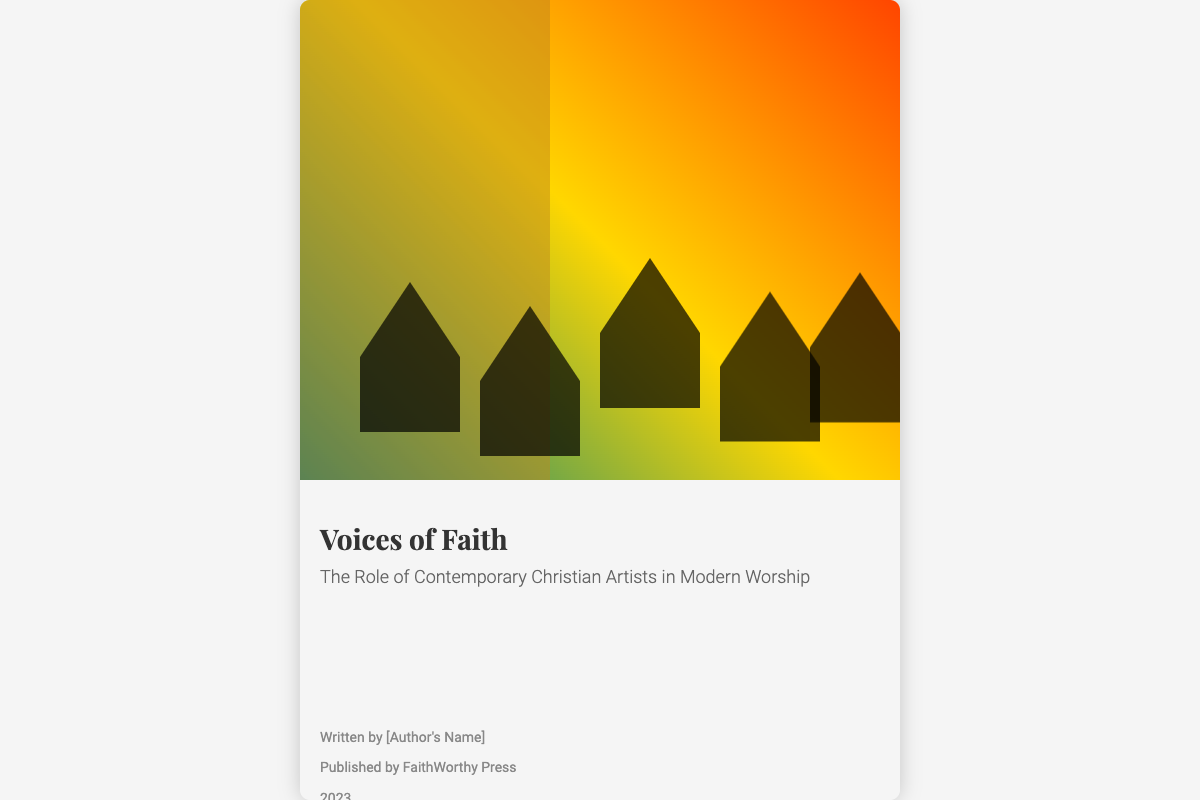What is the title of the book? The title of the book is prominently displayed in a large font on the cover.
Answer: Voices of Faith Who is the publisher? The publisher's name is located toward the bottom section of the cover.
Answer: FaithWorthy Press What year was the book published? The publication date is stated clearly in the text content section.
Answer: 2023 What role do the artists play according to the subtitle? The subtitle explicitly describes the focus of the content on the role of the artists in a specific context.
Answer: Modern Worship How many diverse artist silhouettes are shown? The cover features a specific number of silhouettes representing artists in the collage.
Answer: Five What do the abstract sound waves represent? The design elements convey a particular concept related to the theme of the book.
Answer: Unity and diversity in worship Which color is NOT used in the background gradient? The background gradient consists of specific colors that make up the visual design.
Answer: Blue 